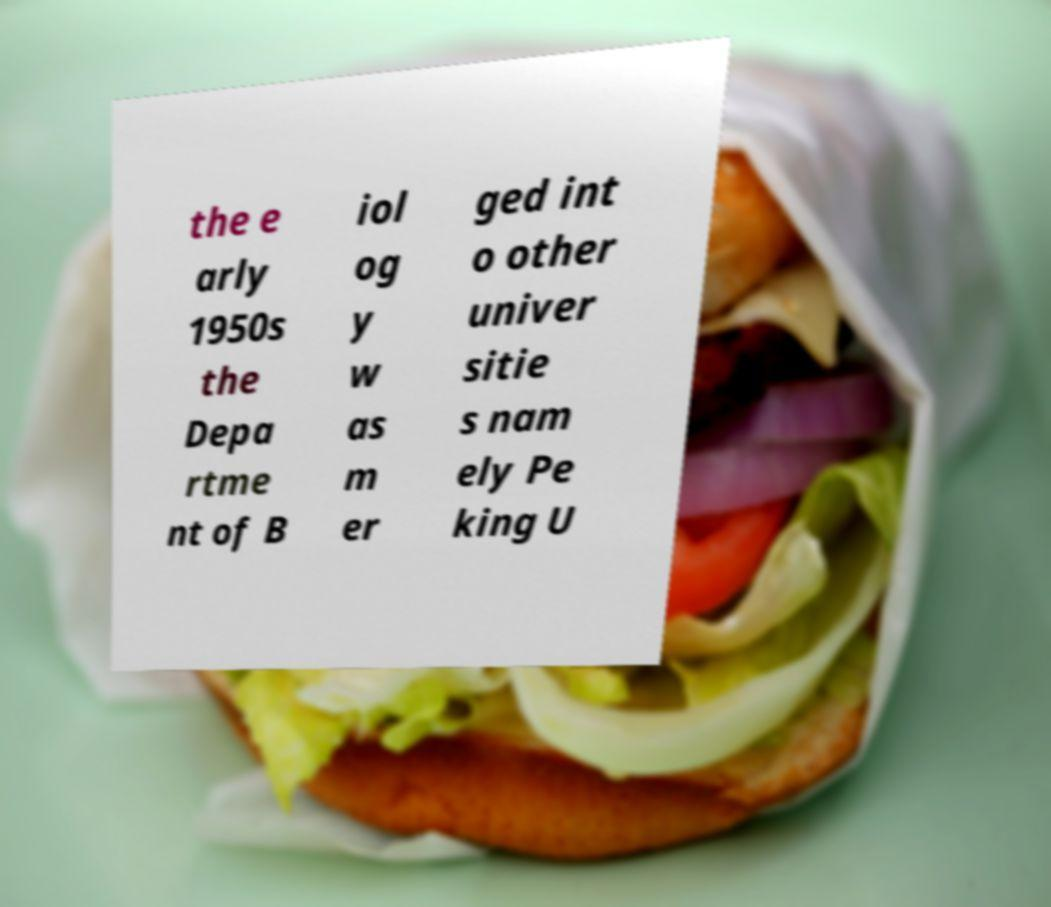For documentation purposes, I need the text within this image transcribed. Could you provide that? the e arly 1950s the Depa rtme nt of B iol og y w as m er ged int o other univer sitie s nam ely Pe king U 